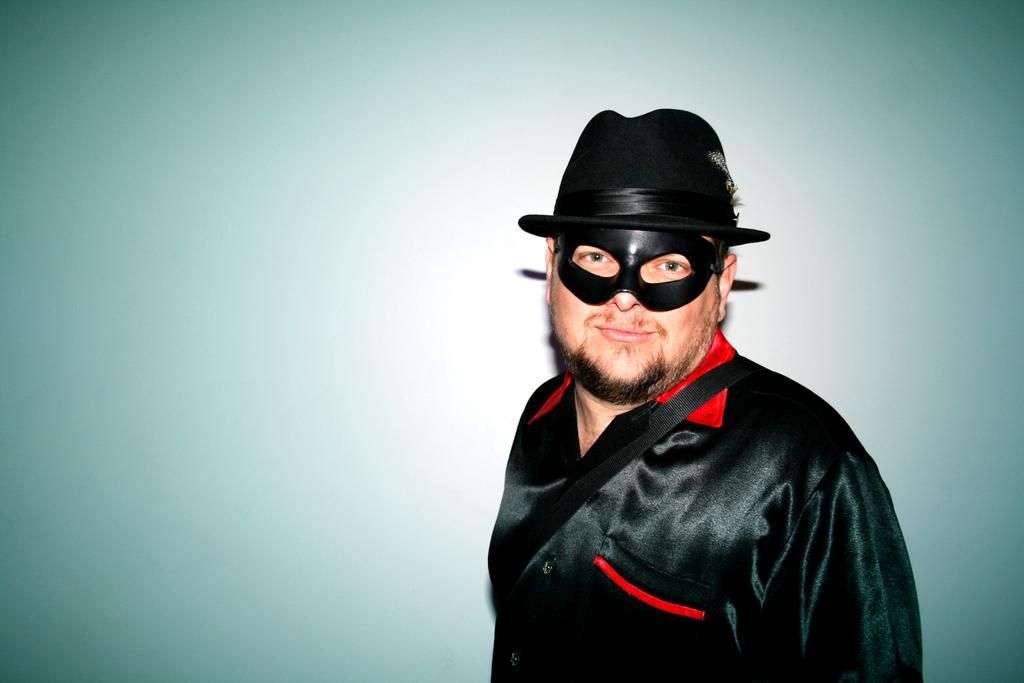What is the main subject of the image? There is a man in the image. What is the man wearing on his face? The man is wearing a black mask. What type of clothing is the man wearing? The man is wearing a black dress. What accessories is the man wearing? The man is wearing a hat and a black bag strap. What is the man's posture in the image? The man is standing. What can be seen behind the man in the image? The background of the image appears to be a wall. What type of steel is the man holding in the image? There is no steel present in the image. What type of substance is the man preaching about in the image? There is no indication in the image that the man is a minister or preaching about any substance. 